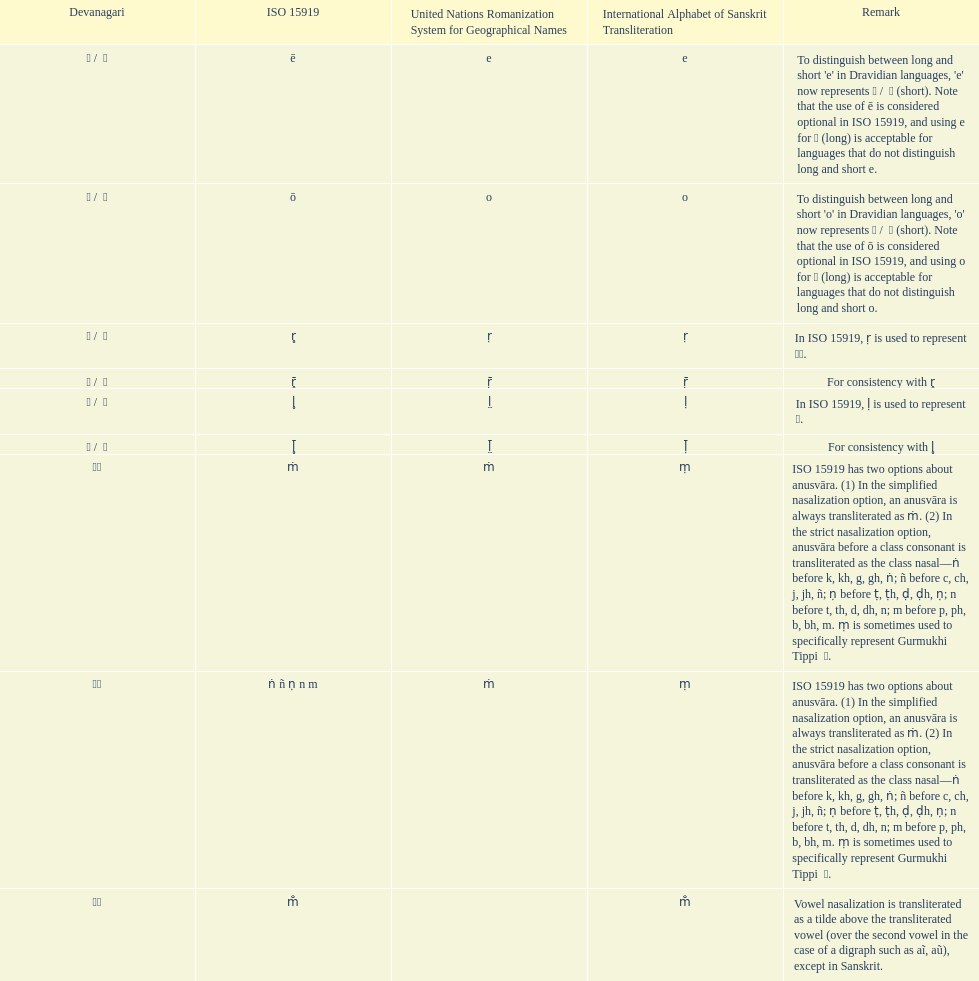Which devanagaria means the same as this iast letter: o? ओ / ो. 